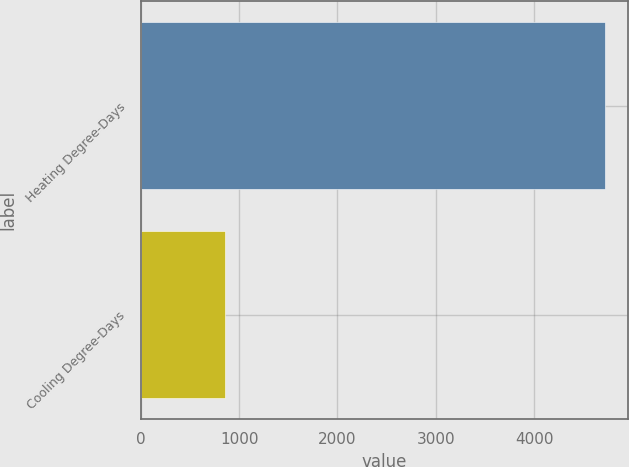Convert chart to OTSL. <chart><loc_0><loc_0><loc_500><loc_500><bar_chart><fcel>Heating Degree-Days<fcel>Cooling Degree-Days<nl><fcel>4720<fcel>853<nl></chart> 